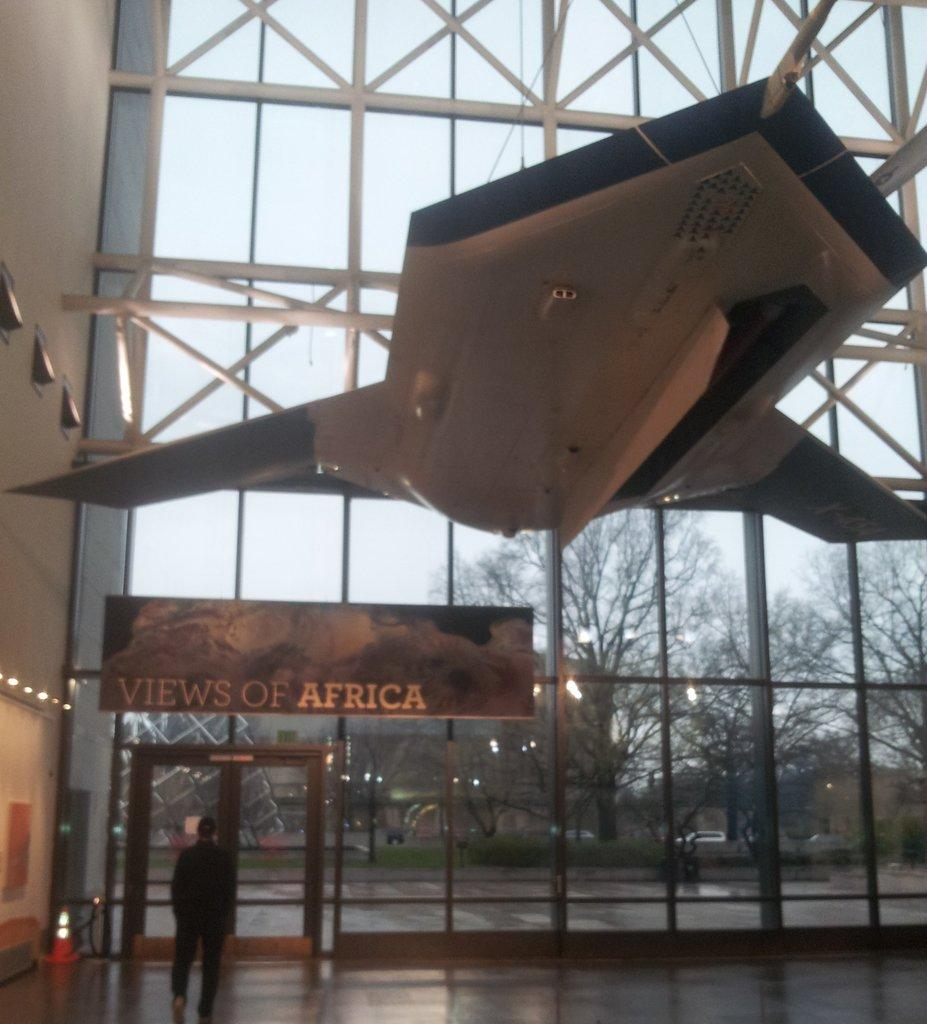<image>
Write a terse but informative summary of the picture. A views of Africa sign underneath a plane. 